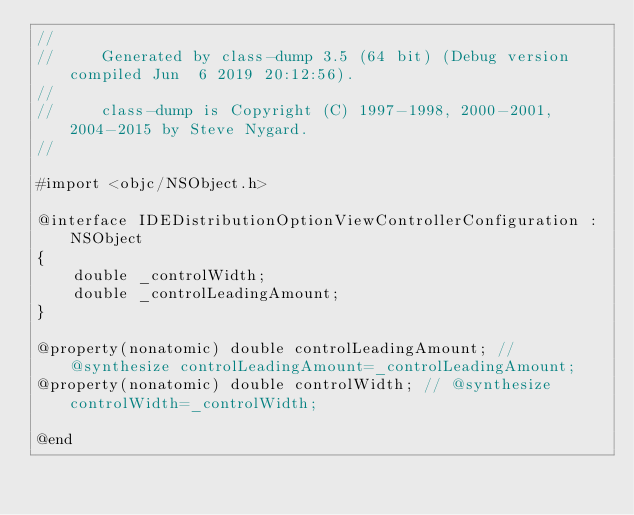Convert code to text. <code><loc_0><loc_0><loc_500><loc_500><_C_>//
//     Generated by class-dump 3.5 (64 bit) (Debug version compiled Jun  6 2019 20:12:56).
//
//     class-dump is Copyright (C) 1997-1998, 2000-2001, 2004-2015 by Steve Nygard.
//

#import <objc/NSObject.h>

@interface IDEDistributionOptionViewControllerConfiguration : NSObject
{
    double _controlWidth;
    double _controlLeadingAmount;
}

@property(nonatomic) double controlLeadingAmount; // @synthesize controlLeadingAmount=_controlLeadingAmount;
@property(nonatomic) double controlWidth; // @synthesize controlWidth=_controlWidth;

@end

</code> 